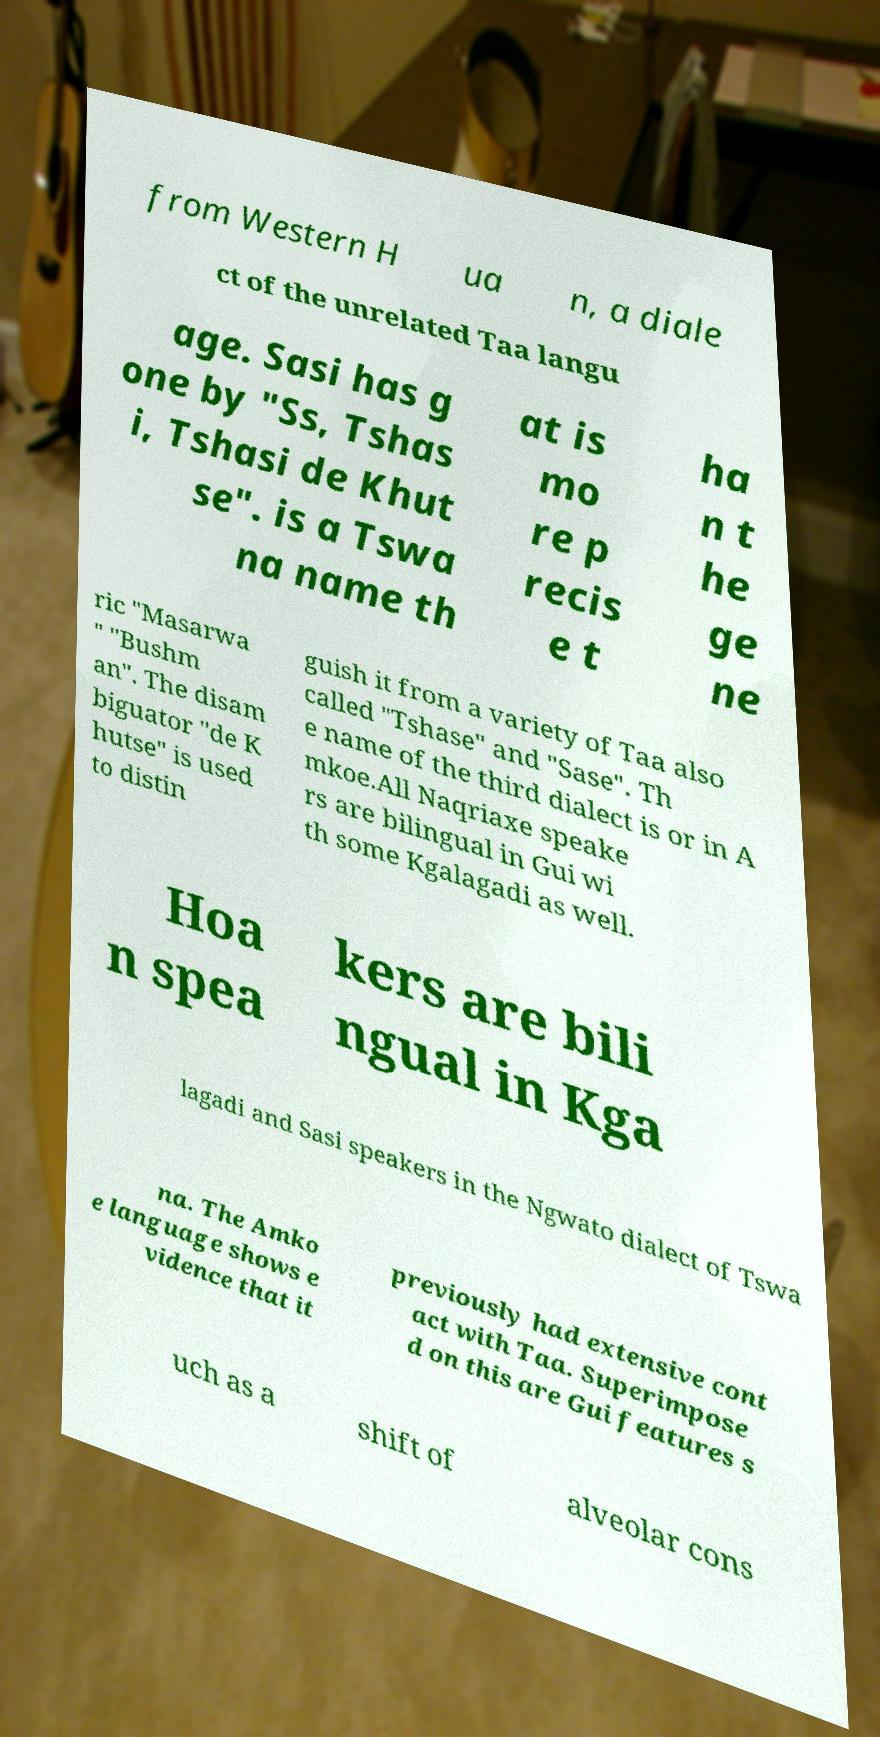Could you extract and type out the text from this image? from Western H ua n, a diale ct of the unrelated Taa langu age. Sasi has g one by "Ss, Tshas i, Tshasi de Khut se". is a Tswa na name th at is mo re p recis e t ha n t he ge ne ric "Masarwa " "Bushm an". The disam biguator "de K hutse" is used to distin guish it from a variety of Taa also called "Tshase" and "Sase". Th e name of the third dialect is or in A mkoe.All Naqriaxe speake rs are bilingual in Gui wi th some Kgalagadi as well. Hoa n spea kers are bili ngual in Kga lagadi and Sasi speakers in the Ngwato dialect of Tswa na. The Amko e language shows e vidence that it previously had extensive cont act with Taa. Superimpose d on this are Gui features s uch as a shift of alveolar cons 